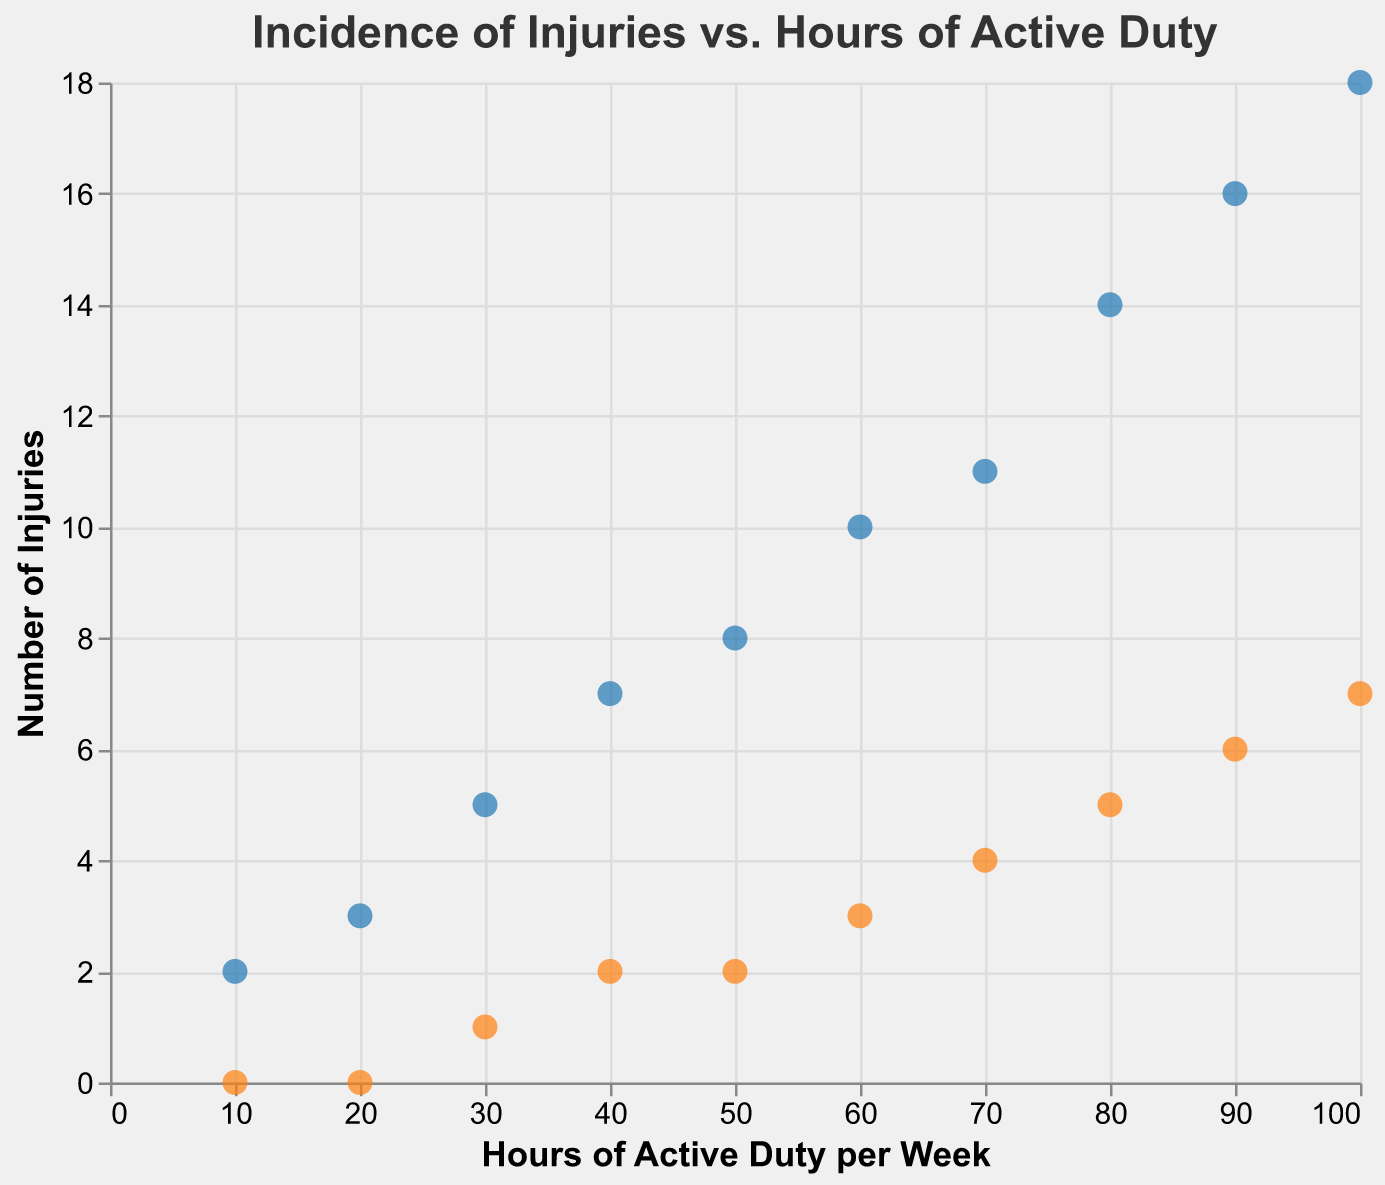What's the title of the figure? The title of the figure is displayed at the top.
Answer: Incidence of Injuries vs. Hours of Active Duty How many data points are plotted for each type of injury? Each data point represents the number of injuries at specific hours of active duty. There are 10 entries for both Minor and Major injuries.
Answer: 10 What color represents Major Injuries in the scatter plot? The scatter plot uses orange for Major Injuries and blue for Minor Injuries.
Answer: Orange What are the axis titles for the scatter plot? The x-axis title is "Hours of Active Duty per Week" and the y-axis title is "Number of Injuries".
Answer: Hours of Active Duty per Week; Number of Injuries Which type of injury increases more rapidly as hours of active duty increase, Minor or Major? By comparing the slopes of the two sets of points, the rate of increase appears steeper for Minor Injuries than Major Injuries.
Answer: Minor Injuries What is the maximum number of Minor Injuries observed, and at how many hours of active duty did it occur? The maximum number of Minor Injuries is 18, which occurs at 100 hours of active duty per week.
Answer: 18; 100 hours Does any data point indicate zero injuries, and if so, for how many hours of active duty? There is one data point where Major Injuries are zero, which occurs at 10 and 20 hours of active duty.
Answer: Yes; 10 and 20 hours For which hours of active duty are Major Injuries the same as Minor Injuries? For Minor Injuries to match Major Injuries, we need to look at points where y-values overlap. This does not occur in the given data.
Answer: None Calculate the average number of Minor Injuries across all data points. Sum the Minor Injuries (2 + 3 + 5 + 7 + 8 + 10 + 11 + 14 + 16 + 18) = 94 and divide by the number of points (10).
Answer: 9.4 Compare the number of Major Injuries at 50 hours and 80 hours of active duty. Which is greater? Check the y-values for both points: 2 Major Injuries at 50 hours and 5 Major Injuries at 80 hours.
Answer: 80 hours 